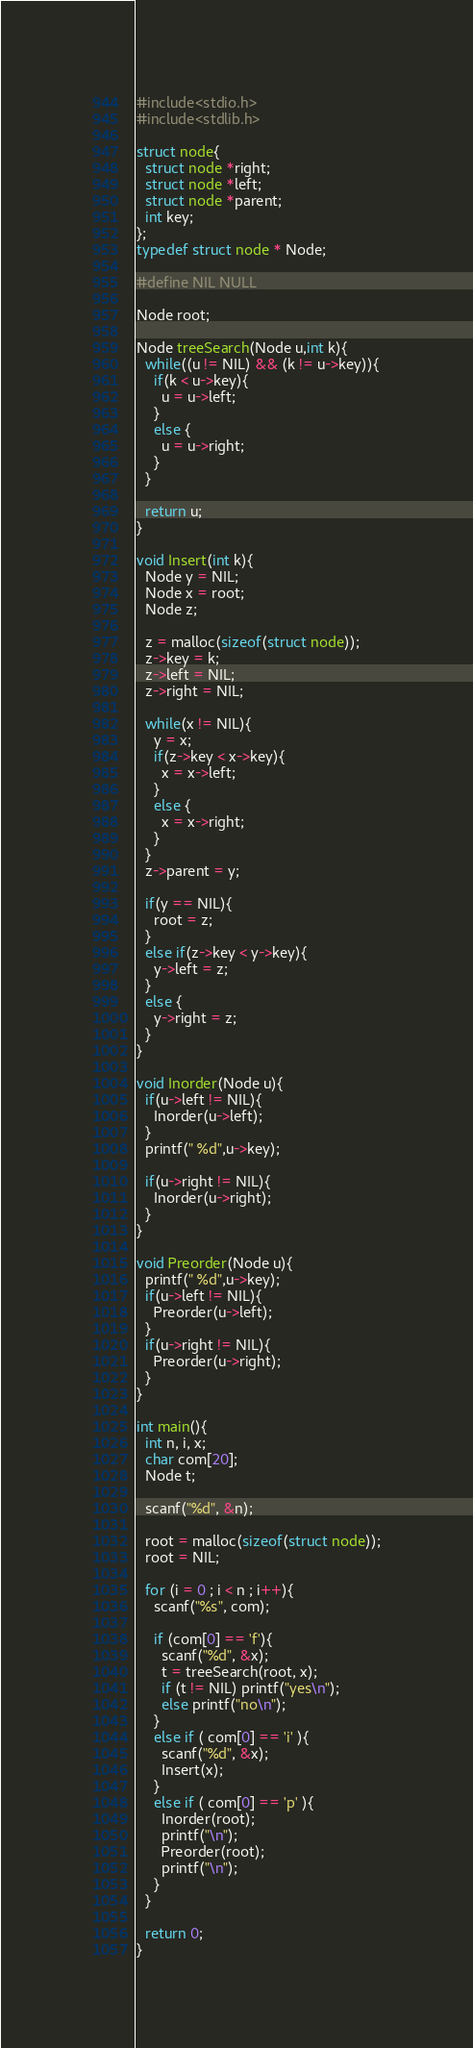<code> <loc_0><loc_0><loc_500><loc_500><_C_>#include<stdio.h>
#include<stdlib.h>

struct node{
  struct node *right;
  struct node *left;
  struct node *parent;
  int key;
};
typedef struct node * Node;

#define NIL NULL

Node root;

Node treeSearch(Node u,int k){
  while((u != NIL) && (k != u->key)){
    if(k < u->key){
      u = u->left;
    }
    else {
      u = u->right;
    }
  }
  
  return u;
}

void Insert(int k){
  Node y = NIL;
  Node x = root;
  Node z;
  
  z = malloc(sizeof(struct node));
  z->key = k;
  z->left = NIL;
  z->right = NIL;
  
  while(x != NIL){
    y = x;
    if(z->key < x->key){
      x = x->left;
    }
    else {
      x = x->right;
    }
  }
  z->parent = y;
  
  if(y == NIL){
    root = z;
  }
  else if(z->key < y->key){
    y->left = z;
  }
  else {
    y->right = z;
  }
}

void Inorder(Node u){
  if(u->left != NIL){
    Inorder(u->left);
  }
  printf(" %d",u->key);
  
  if(u->right != NIL){
    Inorder(u->right);
  }
}

void Preorder(Node u){
  printf(" %d",u->key);
  if(u->left != NIL){
    Preorder(u->left);
  }
  if(u->right != NIL){
    Preorder(u->right);
  }
}

int main(){
  int n, i, x;
  char com[20];
  Node t;
  
  scanf("%d", &n);
  
  root = malloc(sizeof(struct node));
  root = NIL;
  
  for (i = 0 ; i < n ; i++){
    scanf("%s", com);
    
    if (com[0] == 'f'){
      scanf("%d", &x);
      t = treeSearch(root, x);
      if (t != NIL) printf("yes\n");
      else printf("no\n");
    } 
    else if ( com[0] == 'i' ){
      scanf("%d", &x);
      Insert(x);
    } 
    else if ( com[0] == 'p' ){
      Inorder(root);
      printf("\n");
      Preorder(root);
      printf("\n");
    } 
  }
  
  return 0;
}</code> 